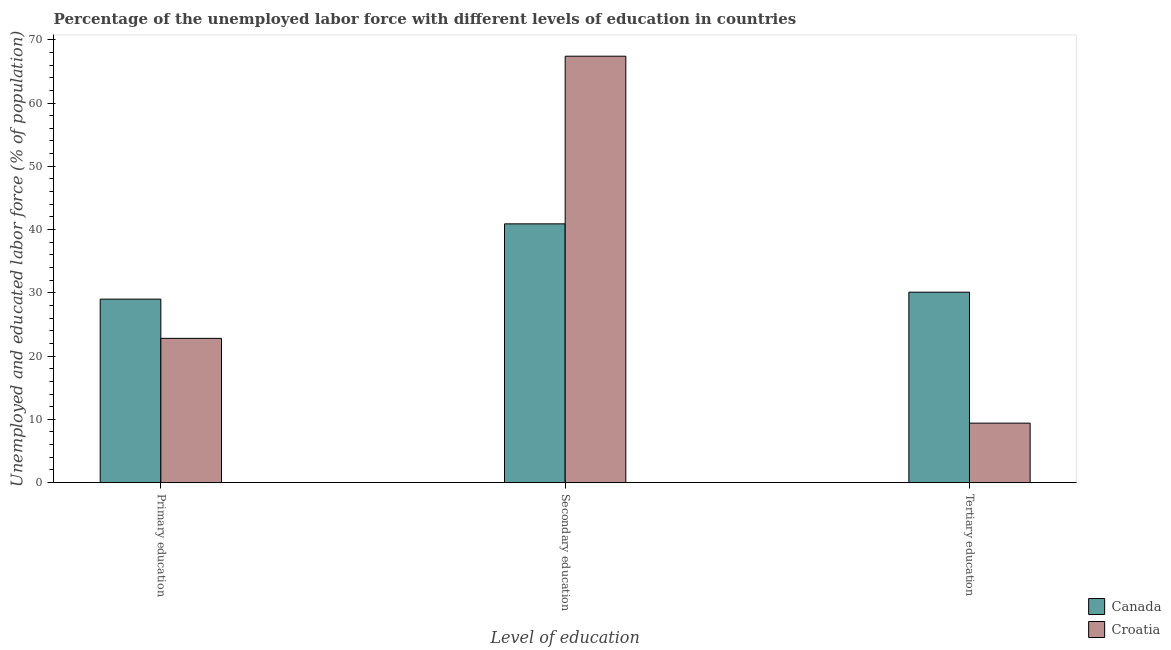How many groups of bars are there?
Ensure brevity in your answer.  3. Are the number of bars on each tick of the X-axis equal?
Keep it short and to the point. Yes. How many bars are there on the 3rd tick from the left?
Ensure brevity in your answer.  2. What is the percentage of labor force who received tertiary education in Canada?
Offer a terse response. 30.1. Across all countries, what is the maximum percentage of labor force who received secondary education?
Your answer should be compact. 67.4. Across all countries, what is the minimum percentage of labor force who received secondary education?
Make the answer very short. 40.9. In which country was the percentage of labor force who received tertiary education maximum?
Give a very brief answer. Canada. What is the total percentage of labor force who received secondary education in the graph?
Your answer should be very brief. 108.3. What is the difference between the percentage of labor force who received tertiary education in Croatia and that in Canada?
Your answer should be very brief. -20.7. What is the difference between the percentage of labor force who received tertiary education in Croatia and the percentage of labor force who received secondary education in Canada?
Give a very brief answer. -31.5. What is the average percentage of labor force who received primary education per country?
Offer a very short reply. 25.9. What is the difference between the percentage of labor force who received tertiary education and percentage of labor force who received secondary education in Canada?
Ensure brevity in your answer.  -10.8. In how many countries, is the percentage of labor force who received tertiary education greater than 2 %?
Ensure brevity in your answer.  2. What is the ratio of the percentage of labor force who received tertiary education in Canada to that in Croatia?
Your answer should be very brief. 3.2. Is the percentage of labor force who received primary education in Canada less than that in Croatia?
Your answer should be very brief. No. Is the difference between the percentage of labor force who received secondary education in Canada and Croatia greater than the difference between the percentage of labor force who received tertiary education in Canada and Croatia?
Provide a short and direct response. No. What is the difference between the highest and the second highest percentage of labor force who received tertiary education?
Your answer should be very brief. 20.7. What is the difference between the highest and the lowest percentage of labor force who received secondary education?
Offer a terse response. 26.5. In how many countries, is the percentage of labor force who received secondary education greater than the average percentage of labor force who received secondary education taken over all countries?
Make the answer very short. 1. Is the sum of the percentage of labor force who received tertiary education in Croatia and Canada greater than the maximum percentage of labor force who received primary education across all countries?
Your answer should be compact. Yes. What does the 2nd bar from the left in Primary education represents?
Offer a terse response. Croatia. How many bars are there?
Your response must be concise. 6. Are all the bars in the graph horizontal?
Your response must be concise. No. How many countries are there in the graph?
Provide a short and direct response. 2. Are the values on the major ticks of Y-axis written in scientific E-notation?
Make the answer very short. No. Does the graph contain grids?
Offer a very short reply. No. Where does the legend appear in the graph?
Make the answer very short. Bottom right. How many legend labels are there?
Ensure brevity in your answer.  2. How are the legend labels stacked?
Offer a very short reply. Vertical. What is the title of the graph?
Your answer should be very brief. Percentage of the unemployed labor force with different levels of education in countries. What is the label or title of the X-axis?
Give a very brief answer. Level of education. What is the label or title of the Y-axis?
Your answer should be compact. Unemployed and educated labor force (% of population). What is the Unemployed and educated labor force (% of population) of Canada in Primary education?
Your answer should be very brief. 29. What is the Unemployed and educated labor force (% of population) in Croatia in Primary education?
Offer a very short reply. 22.8. What is the Unemployed and educated labor force (% of population) of Canada in Secondary education?
Make the answer very short. 40.9. What is the Unemployed and educated labor force (% of population) of Croatia in Secondary education?
Your answer should be very brief. 67.4. What is the Unemployed and educated labor force (% of population) of Canada in Tertiary education?
Give a very brief answer. 30.1. What is the Unemployed and educated labor force (% of population) in Croatia in Tertiary education?
Offer a terse response. 9.4. Across all Level of education, what is the maximum Unemployed and educated labor force (% of population) in Canada?
Your answer should be very brief. 40.9. Across all Level of education, what is the maximum Unemployed and educated labor force (% of population) of Croatia?
Offer a very short reply. 67.4. Across all Level of education, what is the minimum Unemployed and educated labor force (% of population) of Canada?
Ensure brevity in your answer.  29. Across all Level of education, what is the minimum Unemployed and educated labor force (% of population) in Croatia?
Your response must be concise. 9.4. What is the total Unemployed and educated labor force (% of population) in Croatia in the graph?
Provide a short and direct response. 99.6. What is the difference between the Unemployed and educated labor force (% of population) in Croatia in Primary education and that in Secondary education?
Keep it short and to the point. -44.6. What is the difference between the Unemployed and educated labor force (% of population) of Croatia in Primary education and that in Tertiary education?
Give a very brief answer. 13.4. What is the difference between the Unemployed and educated labor force (% of population) of Canada in Secondary education and that in Tertiary education?
Keep it short and to the point. 10.8. What is the difference between the Unemployed and educated labor force (% of population) in Croatia in Secondary education and that in Tertiary education?
Give a very brief answer. 58. What is the difference between the Unemployed and educated labor force (% of population) of Canada in Primary education and the Unemployed and educated labor force (% of population) of Croatia in Secondary education?
Your answer should be compact. -38.4. What is the difference between the Unemployed and educated labor force (% of population) in Canada in Primary education and the Unemployed and educated labor force (% of population) in Croatia in Tertiary education?
Offer a terse response. 19.6. What is the difference between the Unemployed and educated labor force (% of population) of Canada in Secondary education and the Unemployed and educated labor force (% of population) of Croatia in Tertiary education?
Offer a terse response. 31.5. What is the average Unemployed and educated labor force (% of population) of Canada per Level of education?
Your response must be concise. 33.33. What is the average Unemployed and educated labor force (% of population) in Croatia per Level of education?
Give a very brief answer. 33.2. What is the difference between the Unemployed and educated labor force (% of population) in Canada and Unemployed and educated labor force (% of population) in Croatia in Secondary education?
Your answer should be very brief. -26.5. What is the difference between the Unemployed and educated labor force (% of population) in Canada and Unemployed and educated labor force (% of population) in Croatia in Tertiary education?
Give a very brief answer. 20.7. What is the ratio of the Unemployed and educated labor force (% of population) of Canada in Primary education to that in Secondary education?
Your answer should be compact. 0.71. What is the ratio of the Unemployed and educated labor force (% of population) in Croatia in Primary education to that in Secondary education?
Provide a succinct answer. 0.34. What is the ratio of the Unemployed and educated labor force (% of population) in Canada in Primary education to that in Tertiary education?
Offer a terse response. 0.96. What is the ratio of the Unemployed and educated labor force (% of population) of Croatia in Primary education to that in Tertiary education?
Make the answer very short. 2.43. What is the ratio of the Unemployed and educated labor force (% of population) in Canada in Secondary education to that in Tertiary education?
Your response must be concise. 1.36. What is the ratio of the Unemployed and educated labor force (% of population) of Croatia in Secondary education to that in Tertiary education?
Offer a terse response. 7.17. What is the difference between the highest and the second highest Unemployed and educated labor force (% of population) of Canada?
Offer a very short reply. 10.8. What is the difference between the highest and the second highest Unemployed and educated labor force (% of population) of Croatia?
Your answer should be compact. 44.6. What is the difference between the highest and the lowest Unemployed and educated labor force (% of population) in Croatia?
Offer a terse response. 58. 